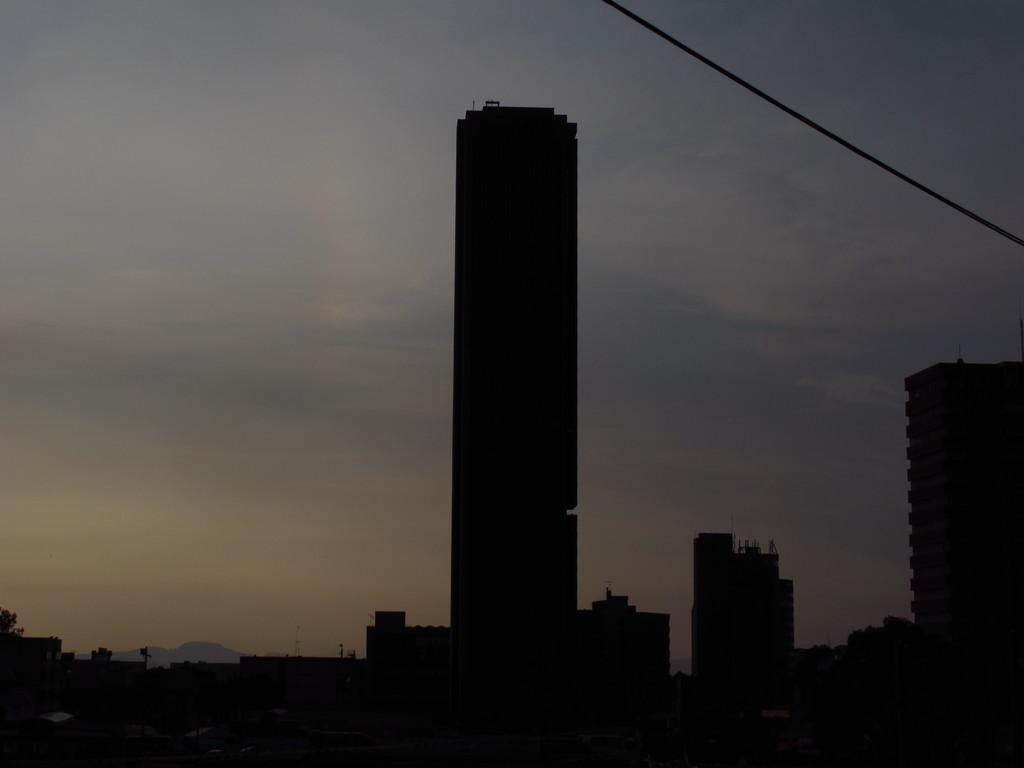What type of structures are visible in the image? There are buildings and tower buildings in the image. How are the buildings and tower buildings characterized? The buildings and tower buildings are dark. What is visible in the background of the image? There is a sky visible in the image. What can be seen in the sky? Clouds are present in the sky. What time of day is it in the image, considering the presence of the afternoon sun? There is no mention of an afternoon sun in the image, and the time of day cannot be determined from the provided facts. 